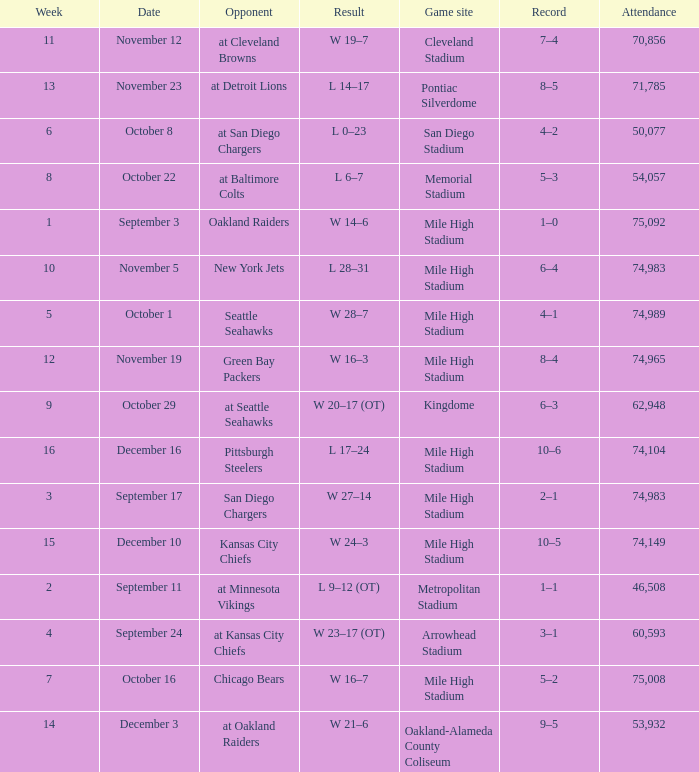On what date was the result w 28–7? October 1. Parse the full table. {'header': ['Week', 'Date', 'Opponent', 'Result', 'Game site', 'Record', 'Attendance'], 'rows': [['11', 'November 12', 'at Cleveland Browns', 'W 19–7', 'Cleveland Stadium', '7–4', '70,856'], ['13', 'November 23', 'at Detroit Lions', 'L 14–17', 'Pontiac Silverdome', '8–5', '71,785'], ['6', 'October 8', 'at San Diego Chargers', 'L 0–23', 'San Diego Stadium', '4–2', '50,077'], ['8', 'October 22', 'at Baltimore Colts', 'L 6–7', 'Memorial Stadium', '5–3', '54,057'], ['1', 'September 3', 'Oakland Raiders', 'W 14–6', 'Mile High Stadium', '1–0', '75,092'], ['10', 'November 5', 'New York Jets', 'L 28–31', 'Mile High Stadium', '6–4', '74,983'], ['5', 'October 1', 'Seattle Seahawks', 'W 28–7', 'Mile High Stadium', '4–1', '74,989'], ['12', 'November 19', 'Green Bay Packers', 'W 16–3', 'Mile High Stadium', '8–4', '74,965'], ['9', 'October 29', 'at Seattle Seahawks', 'W 20–17 (OT)', 'Kingdome', '6–3', '62,948'], ['16', 'December 16', 'Pittsburgh Steelers', 'L 17–24', 'Mile High Stadium', '10–6', '74,104'], ['3', 'September 17', 'San Diego Chargers', 'W 27–14', 'Mile High Stadium', '2–1', '74,983'], ['15', 'December 10', 'Kansas City Chiefs', 'W 24–3', 'Mile High Stadium', '10–5', '74,149'], ['2', 'September 11', 'at Minnesota Vikings', 'L 9–12 (OT)', 'Metropolitan Stadium', '1–1', '46,508'], ['4', 'September 24', 'at Kansas City Chiefs', 'W 23–17 (OT)', 'Arrowhead Stadium', '3–1', '60,593'], ['7', 'October 16', 'Chicago Bears', 'W 16–7', 'Mile High Stadium', '5–2', '75,008'], ['14', 'December 3', 'at Oakland Raiders', 'W 21–6', 'Oakland-Alameda County Coliseum', '9–5', '53,932']]} 